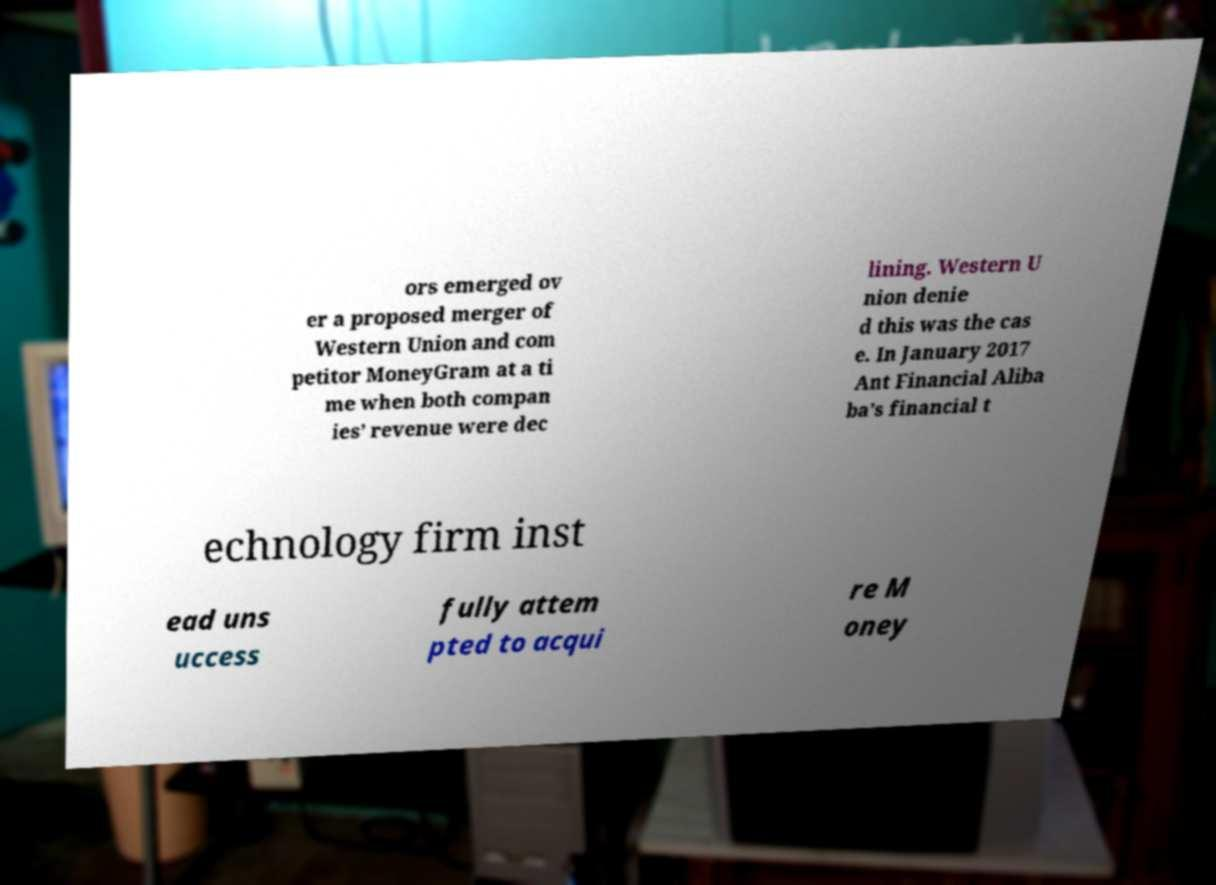Could you extract and type out the text from this image? ors emerged ov er a proposed merger of Western Union and com petitor MoneyGram at a ti me when both compan ies’ revenue were dec lining. Western U nion denie d this was the cas e. In January 2017 Ant Financial Aliba ba’s financial t echnology firm inst ead uns uccess fully attem pted to acqui re M oney 